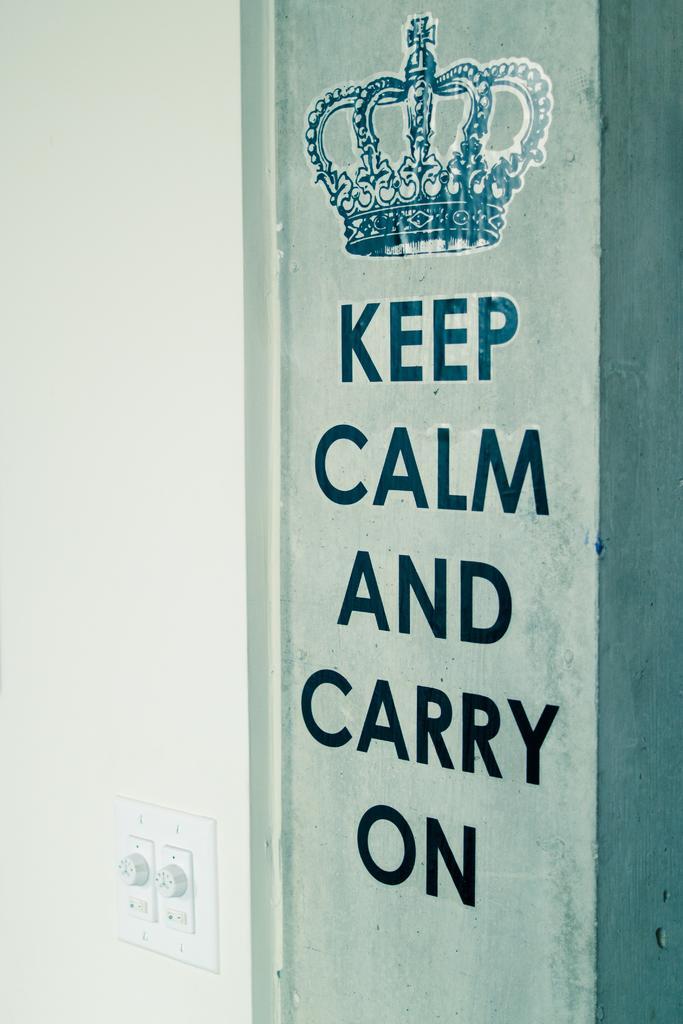How would you summarize this image in a sentence or two? In this picture we can see few switches and some text on the wall. 